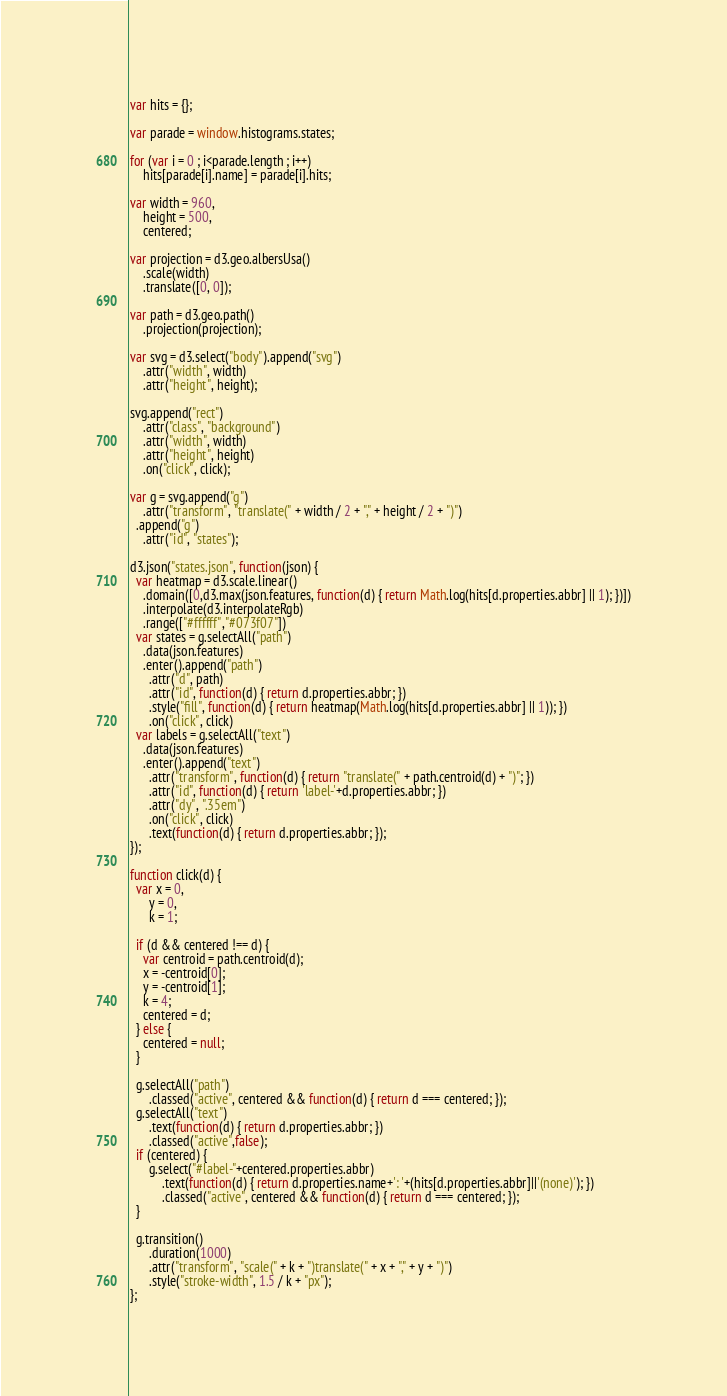Convert code to text. <code><loc_0><loc_0><loc_500><loc_500><_JavaScript_>var hits = {};

var parade = window.histograms.states;

for (var i = 0 ; i<parade.length ; i++)
    hits[parade[i].name] = parade[i].hits;

var width = 960,
    height = 500,
    centered;

var projection = d3.geo.albersUsa()
    .scale(width)
    .translate([0, 0]);

var path = d3.geo.path()
    .projection(projection);

var svg = d3.select("body").append("svg")
    .attr("width", width)
    .attr("height", height);

svg.append("rect")
    .attr("class", "background")
    .attr("width", width)
    .attr("height", height)
    .on("click", click);

var g = svg.append("g")
    .attr("transform", "translate(" + width / 2 + "," + height / 2 + ")")
  .append("g")
    .attr("id", "states");

d3.json("states.json", function(json) {
  var heatmap = d3.scale.linear()
    .domain([0,d3.max(json.features, function(d) { return Math.log(hits[d.properties.abbr] || 1); })])
    .interpolate(d3.interpolateRgb)
    .range(["#ffffff","#073f07"])
  var states = g.selectAll("path")
    .data(json.features)
    .enter().append("path")
      .attr("d", path)
      .attr("id", function(d) { return d.properties.abbr; })
      .style("fill", function(d) { return heatmap(Math.log(hits[d.properties.abbr] || 1)); })
      .on("click", click)
  var labels = g.selectAll("text")
    .data(json.features)
    .enter().append("text")
      .attr("transform", function(d) { return "translate(" + path.centroid(d) + ")"; })
      .attr("id", function(d) { return 'label-'+d.properties.abbr; })
      .attr("dy", ".35em")
      .on("click", click)
      .text(function(d) { return d.properties.abbr; });
});

function click(d) {
  var x = 0,
      y = 0,
      k = 1;

  if (d && centered !== d) {
    var centroid = path.centroid(d);
    x = -centroid[0];
    y = -centroid[1];
    k = 4;
    centered = d;
  } else {
    centered = null;
  }

  g.selectAll("path")
      .classed("active", centered && function(d) { return d === centered; });
  g.selectAll("text")
      .text(function(d) { return d.properties.abbr; })
      .classed("active",false);
  if (centered) {
      g.select("#label-"+centered.properties.abbr)
          .text(function(d) { return d.properties.name+': '+(hits[d.properties.abbr]||'(none)'); })
          .classed("active", centered && function(d) { return d === centered; });
  }

  g.transition()
      .duration(1000)
      .attr("transform", "scale(" + k + ")translate(" + x + "," + y + ")")
      .style("stroke-width", 1.5 / k + "px");
};</code> 